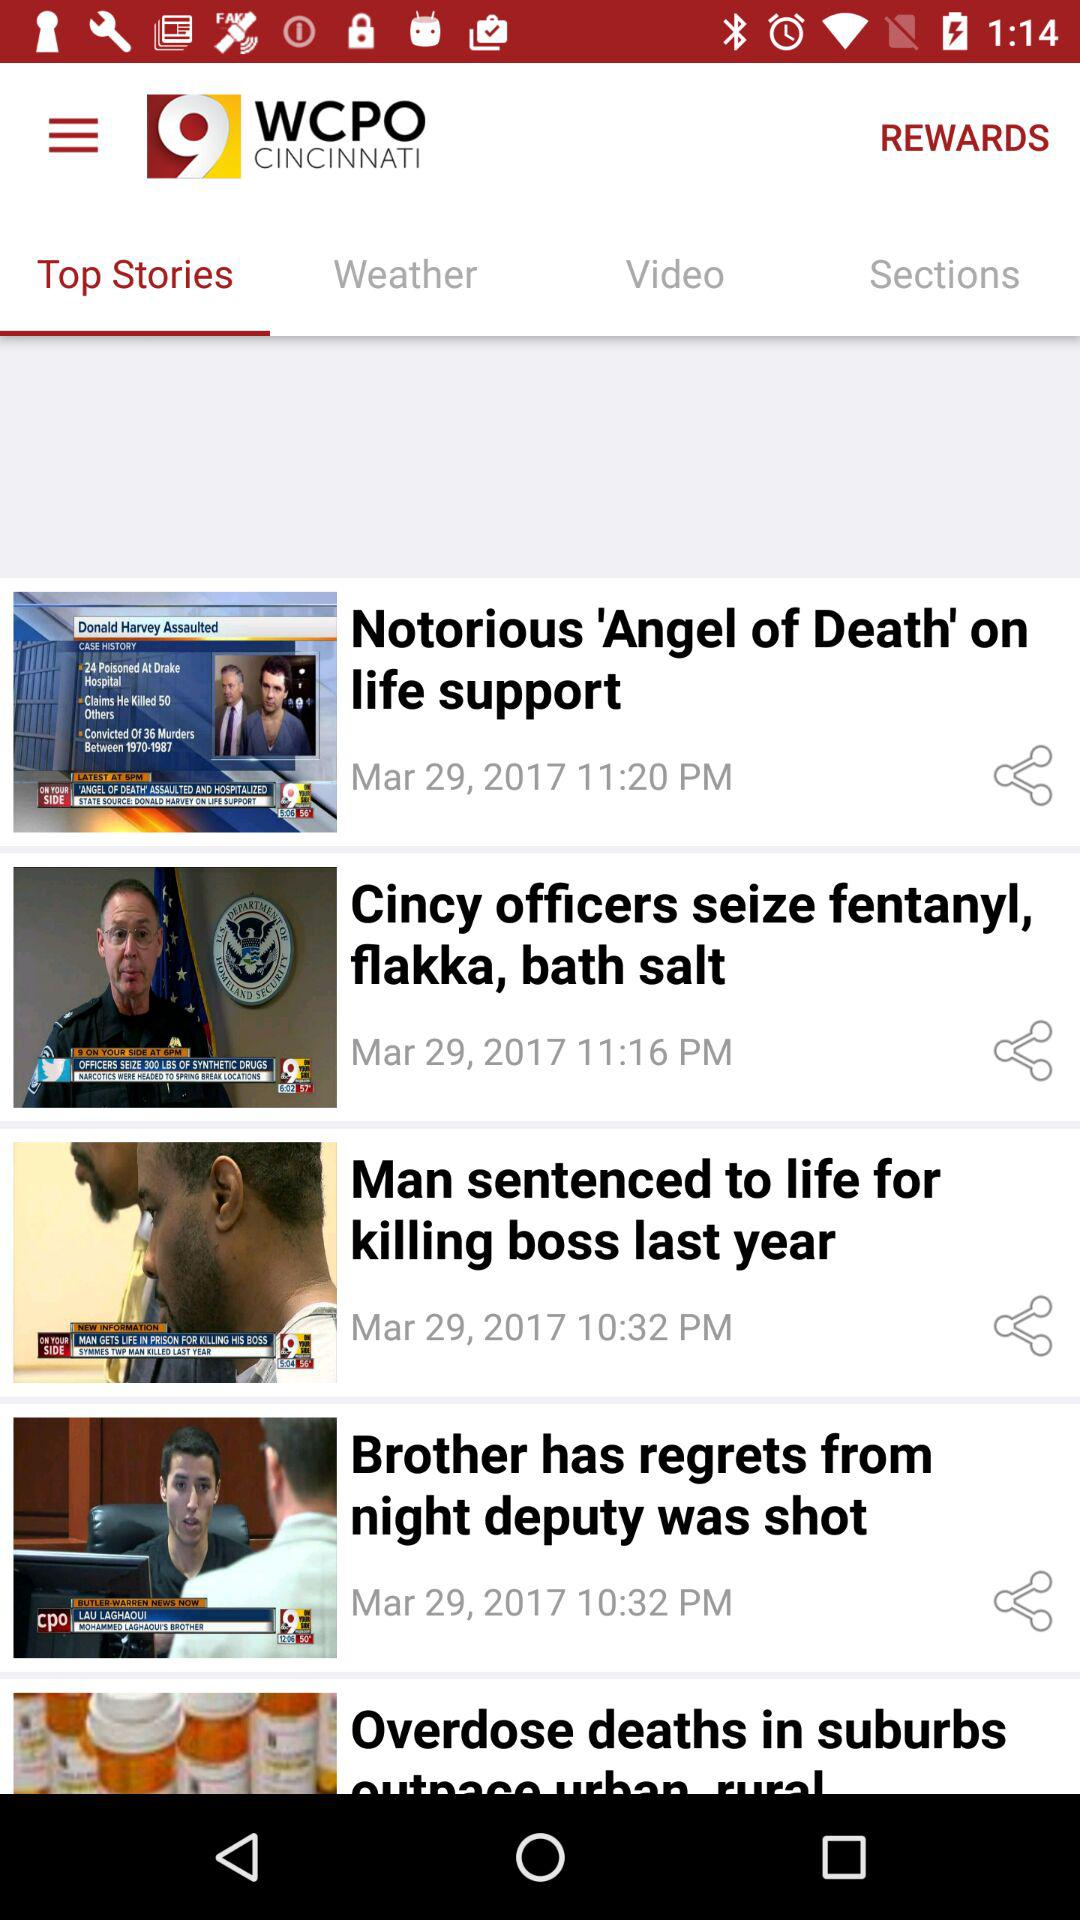When was the article about overdose deaths in the suburbs posted?
When the provided information is insufficient, respond with <no answer>. <no answer> 